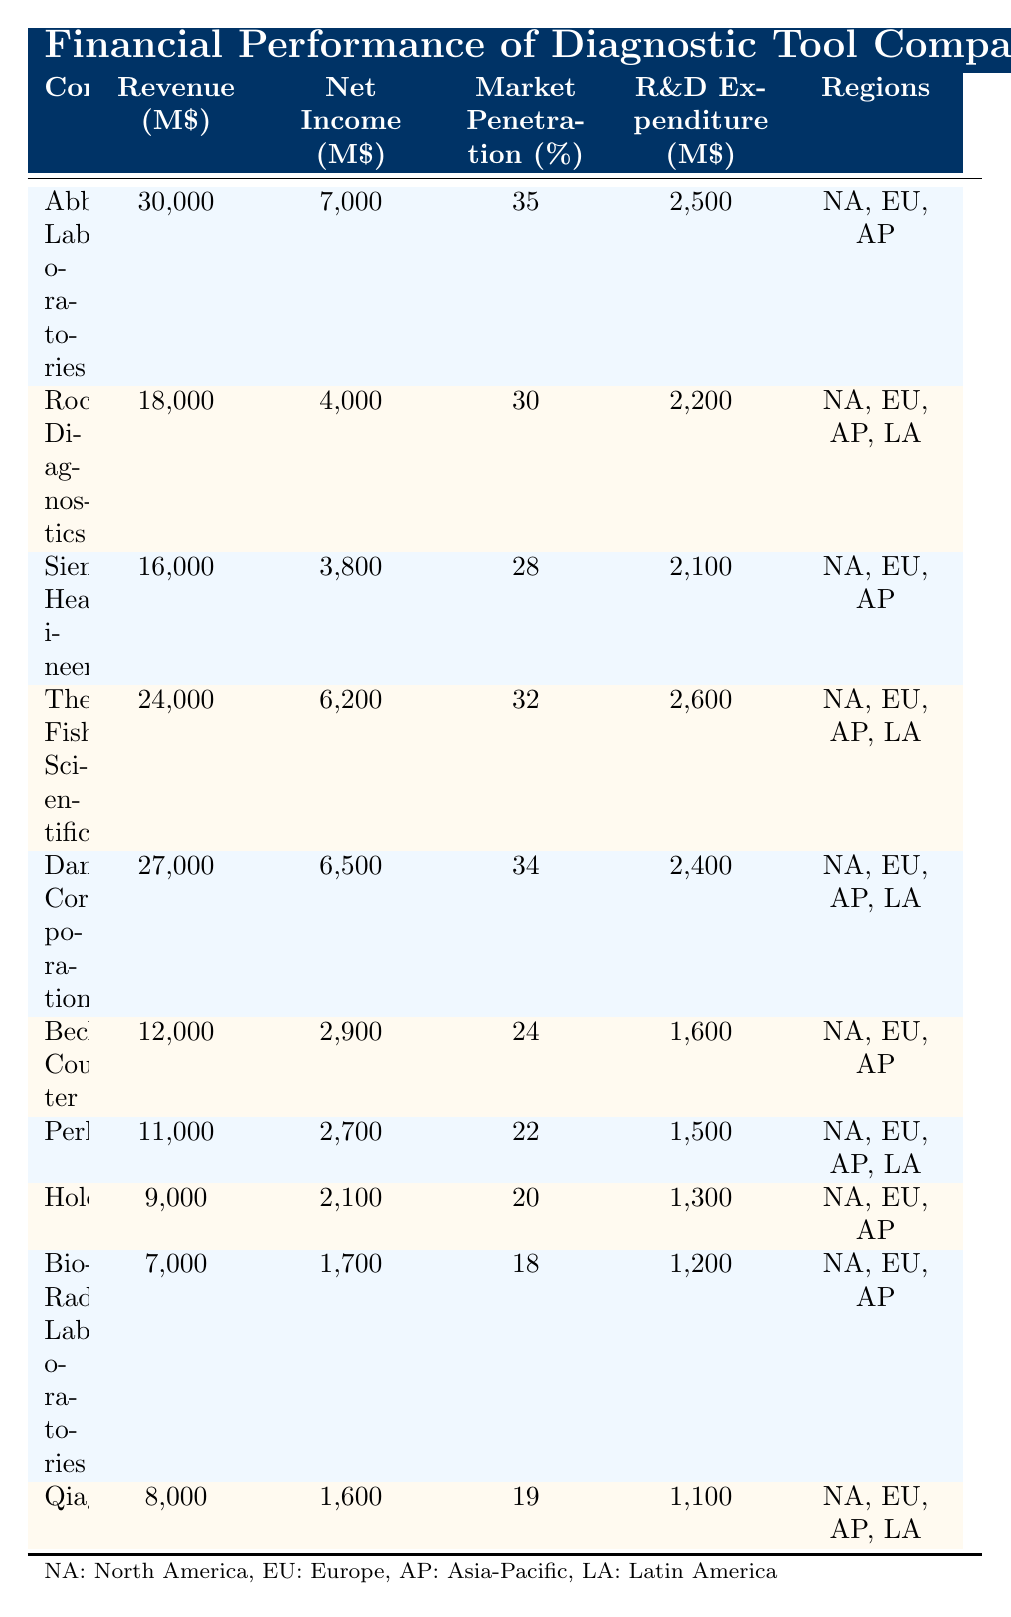What is the revenue of Abbott Laboratories? The revenue for Abbott Laboratories is clearly listed in the table as 30,000 million dollars.
Answer: 30,000 million $ What is the net income of Roche Diagnostics? The net income for Roche Diagnostics is directly stated in the table as 4,000 million dollars.
Answer: 4,000 million $ Which company has the highest market penetration? By comparing the market penetration percentages in the table, Abbott Laboratories has the highest value at 35%.
Answer: Abbott Laboratories What is the average revenue of the companies listed in the table? To find the average revenue, sum all the revenues: 30,000 + 18,000 + 16,000 + 24,000 + 27,000 + 12,000 + 11,000 + 9,000 + 7,000 + 8,000 = 262,000 million dollars. There are 10 companies, so the average is 262,000 / 10 = 26,200 million dollars.
Answer: 26,200 million $ Did Thermo Fisher Scientific have R&D expenditure greater than 2,500 million dollars? The R&D expenditure for Thermo Fisher Scientific is listed as 2,600 million dollars, which is indeed greater than 2,500 million dollars.
Answer: Yes What is the total net income of companies with market penetration greater than 30%? First, identify the companies with market penetration greater than 30%, which are Abbott Laboratories, Thermo Fisher Scientific, Danaher Corporation, and Roche Diagnostics. Their net incomes are 7,000 + 6,200 + 6,500 + 4,000 = 23,700 million dollars.
Answer: 23,700 million $ Is Hologic's market penetration more than that of PerkinElmer? Hologic has a market penetration of 20%, while PerkinElmer has a market penetration of 22%. Thus, Hologic's market penetration is less than that of PerkinElmer.
Answer: No Which company has the lowest revenue, and what is that revenue? By scanning the revenue column, Bio-Rad Laboratories has the lowest revenue at 7,000 million dollars.
Answer: 7,000 million $ What is the difference in net income between Abbott Laboratories and Bio-Rad Laboratories? The net income for Abbott Laboratories is 7,000 million dollars, and for Bio-Rad Laboratories, it is 1,700 million dollars. The difference is 7,000 - 1,700 = 5,300 million dollars.
Answer: 5,300 million $ 